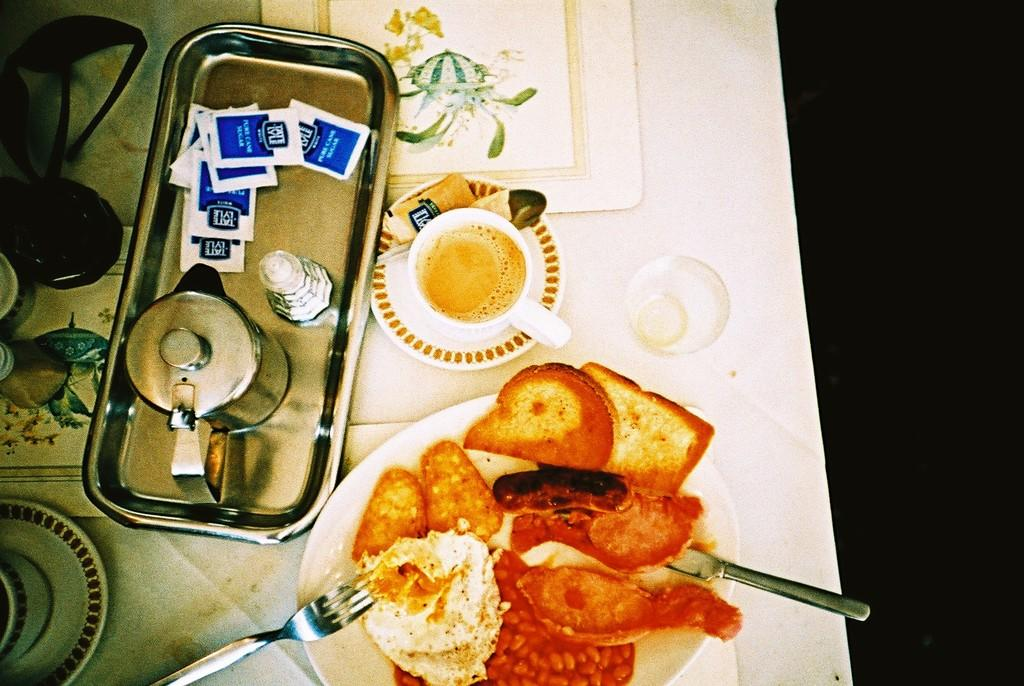What is located on the left side of the image? There is a tea mug on a plate on the left side of the image. What is in the middle of the image? There is a tea cup in a saucer in the middle of the image. What can be seen on the right side of the image? There are food items on a white color plate in the right side of the image. What type of plantation is visible in the image? There is no plantation present in the image. What kind of society is depicted in the image? The image does not depict any society; it features tea mugs, a tea cup, and food items. 